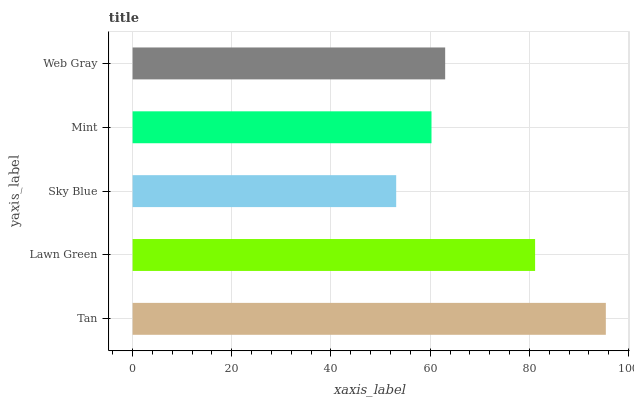Is Sky Blue the minimum?
Answer yes or no. Yes. Is Tan the maximum?
Answer yes or no. Yes. Is Lawn Green the minimum?
Answer yes or no. No. Is Lawn Green the maximum?
Answer yes or no. No. Is Tan greater than Lawn Green?
Answer yes or no. Yes. Is Lawn Green less than Tan?
Answer yes or no. Yes. Is Lawn Green greater than Tan?
Answer yes or no. No. Is Tan less than Lawn Green?
Answer yes or no. No. Is Web Gray the high median?
Answer yes or no. Yes. Is Web Gray the low median?
Answer yes or no. Yes. Is Lawn Green the high median?
Answer yes or no. No. Is Lawn Green the low median?
Answer yes or no. No. 